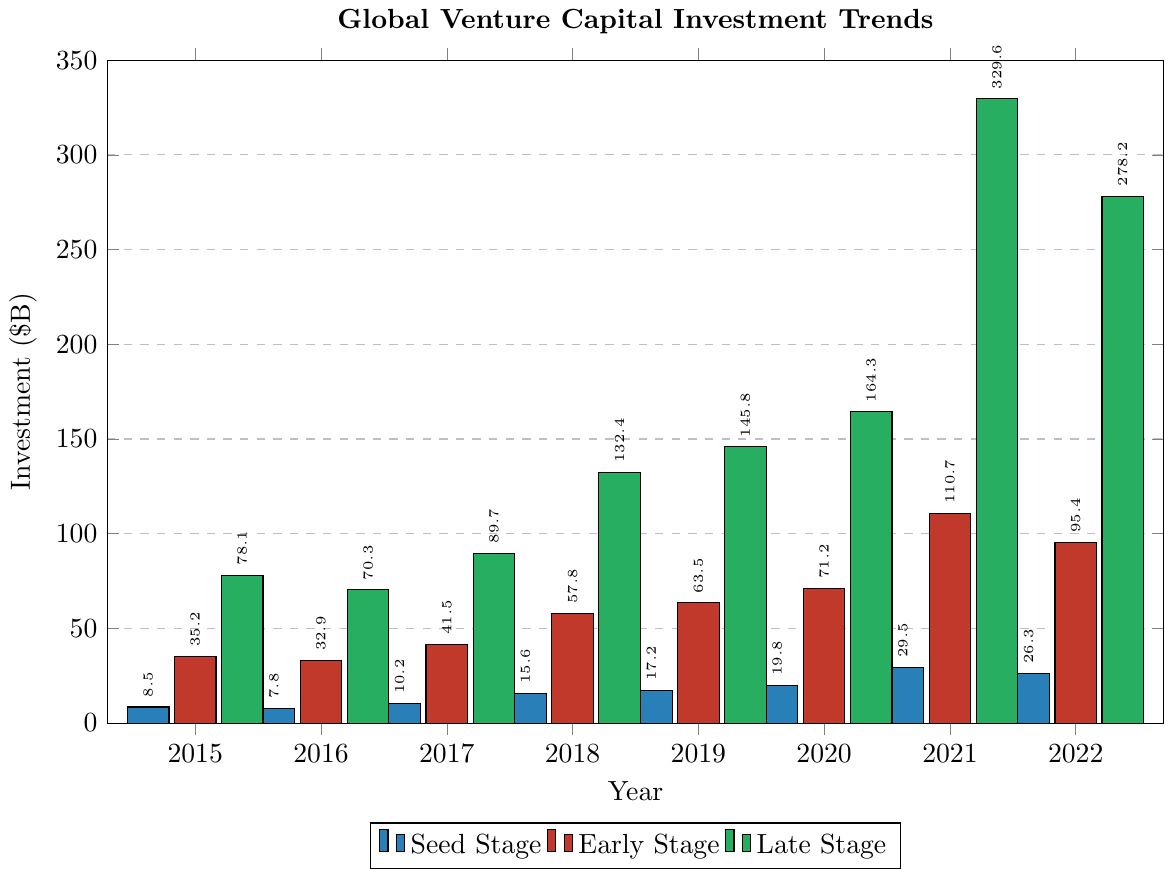What is the total investment in the year 2015? Sum the investments across Seed Stage, Early Stage, and Late Stage for 2015: 8.5 (Seed) + 35.2 (Early) + 78.1 (Late) = 121.8
Answer: 121.8 Between which consecutive years did the Seed Stage investment see the highest growth? Calculate the difference in Seed Stage investments between consecutive years. The differences are: 2016-2015: 7.8-8.5 = -0.7, 2017-2016: 10.2-7.8 = 2.4, 2018-2017: 15.6-10.2 = 5.4, 2019-2018: 17.2-15.6 = 1.6, 2020-2019: 19.8-17.2 = 2.6, 2021-2020: 29.5-19.8 = 9.7, 2022-2021: 26.3-29.5 = -3.2. The highest growth occurs between 2020 and 2021 (9.7).
Answer: 2020 and 2021 Which stage had the highest investment in 2021? Compare the investments for all stages in 2021: Seed Stage is 29.5, Early Stage is 110.7, Late Stage is 329.6. Late Stage has the highest investment.
Answer: Late Stage What is the trend in Early Stage investment from 2015 to 2022? Observe the Early Stage investment values over the years: 2015: 35.2, 2016: 32.9, 2017: 41.5, 2018: 57.8, 2019: 63.5, 2020: 71.2, 2021: 110.7, 2022: 95.4. The investment generally increases with a peak in 2021, followed by a slight drop in 2022.
Answer: Generally increasing trend with a peak in 2021 In which year did Late Stage investment almost double compared to the previous year? Compare Late Stage investment between consecutive years, looking for nearly doubled values: 2016-2015: 70.3/78.1 ≈ 0.90, 2017-2016: 89.7/70.3 ≈ 1.28, 2018-2017: 132.4/89.7 ≈ 1.48, 2019-2018: 145.8/132.4 ≈ 1.10, 2020-2019: 164.3/145.8 ≈ 1.13, 2021-2020: 329.6/164.3 ≈ 2.00, 2022-2021: 278.2/329.6 ≈ 0.84. The investment doubled in 2021 compared to 2020.
Answer: 2021 Which year saw the lowest total investment across all stages? Calculate the total investment for each year and find the minimum: 2015: 8.5+35.2+78.1 = 121.8, 2016: 7.8+32.9+70.3 = 111.0, 2017: 10.2+41.5+89.7 = 141.4, 2018: 15.6+57.8+132.4 = 205.8, 2019: 17.2+63.5+145.8 = 226.5, 2020: 19.8+71.2+164.3 = 255.3, 2021: 29.5+110.7+329.6 = 469.8, 2022: 26.3+95.4+278.2 = 400.0. The year 2016 has the lowest total investment.
Answer: 2016 How did the total investment trend from 2015 to 2022? Observe the total investment values over the years: 2015: 121.8, 2016: 111.0, 2017: 141.4, 2018: 205.8, 2019: 226.5, 2020: 255.3, 2021: 469.8, 2022: 400.0. The investment generally increases with a peak in 2021, followed by a drop in 2022.
Answer: Increasing trend with a peak in 2021 